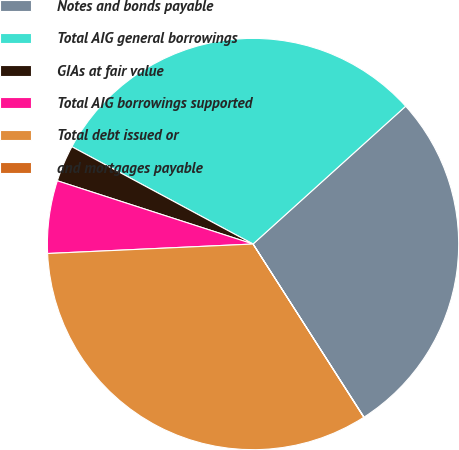Convert chart to OTSL. <chart><loc_0><loc_0><loc_500><loc_500><pie_chart><fcel>Notes and bonds payable<fcel>Total AIG general borrowings<fcel>GIAs at fair value<fcel>Total AIG borrowings supported<fcel>Total debt issued or<fcel>and mortgages payable<nl><fcel>27.62%<fcel>30.47%<fcel>2.87%<fcel>5.71%<fcel>33.32%<fcel>0.02%<nl></chart> 